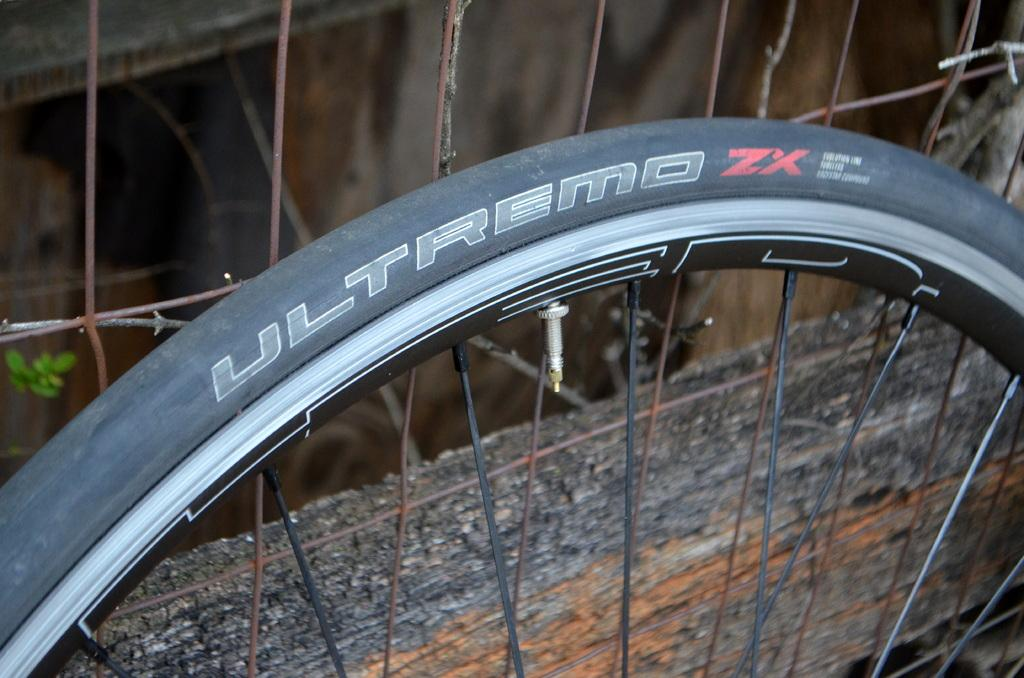What object is the main focus of the image? The main focus of the image is a bicycle tire. Can you describe the background of the image? There is a fence behind the bicycle tire in the image. How many fairies are sitting on the bicycle tire in the image? There are no fairies present in the image; it only features a bicycle tire and a fence in the background. 